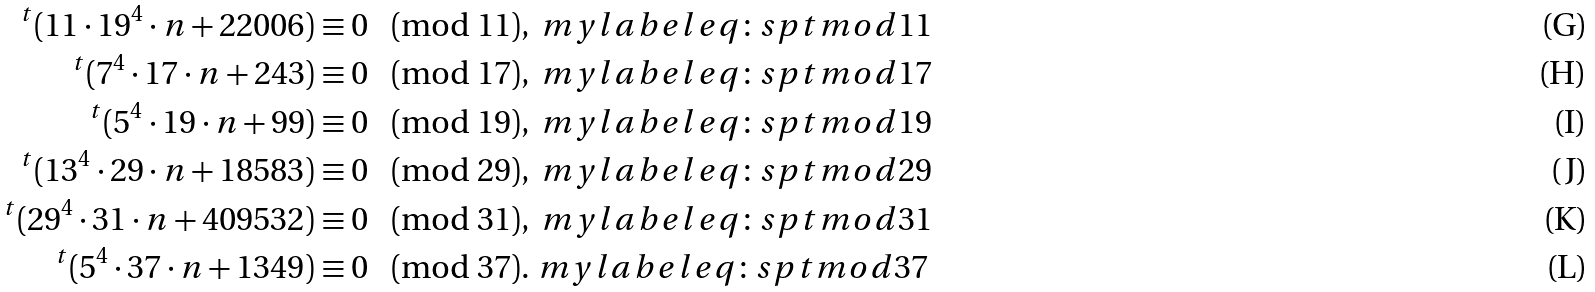<formula> <loc_0><loc_0><loc_500><loc_500>^ { t } ( 1 1 \cdot 1 9 ^ { 4 } \cdot n + 2 2 0 0 6 ) & \equiv 0 \pmod { 1 1 } , \ m y l a b e l { e q \colon s p t m o d 1 1 } \\ ^ { t } ( 7 ^ { 4 } \cdot 1 7 \cdot n + 2 4 3 ) & \equiv 0 \pmod { 1 7 } , \ m y l a b e l { e q \colon s p t m o d 1 7 } \\ ^ { t } ( 5 ^ { 4 } \cdot 1 9 \cdot n + 9 9 ) & \equiv 0 \pmod { 1 9 } , \ m y l a b e l { e q \colon s p t m o d 1 9 } \\ ^ { t } ( 1 3 ^ { 4 } \cdot 2 9 \cdot n + 1 8 5 8 3 ) & \equiv 0 \pmod { 2 9 } , \ m y l a b e l { e q \colon s p t m o d 2 9 } \\ ^ { t } ( 2 9 ^ { 4 } \cdot 3 1 \cdot n + 4 0 9 5 3 2 ) & \equiv 0 \pmod { 3 1 } , \ m y l a b e l { e q \colon s p t m o d 3 1 } \\ ^ { t } ( 5 ^ { 4 } \cdot 3 7 \cdot n + 1 3 4 9 ) & \equiv 0 \pmod { 3 7 } . \ m y l a b e l { e q \colon s p t m o d 3 7 }</formula> 